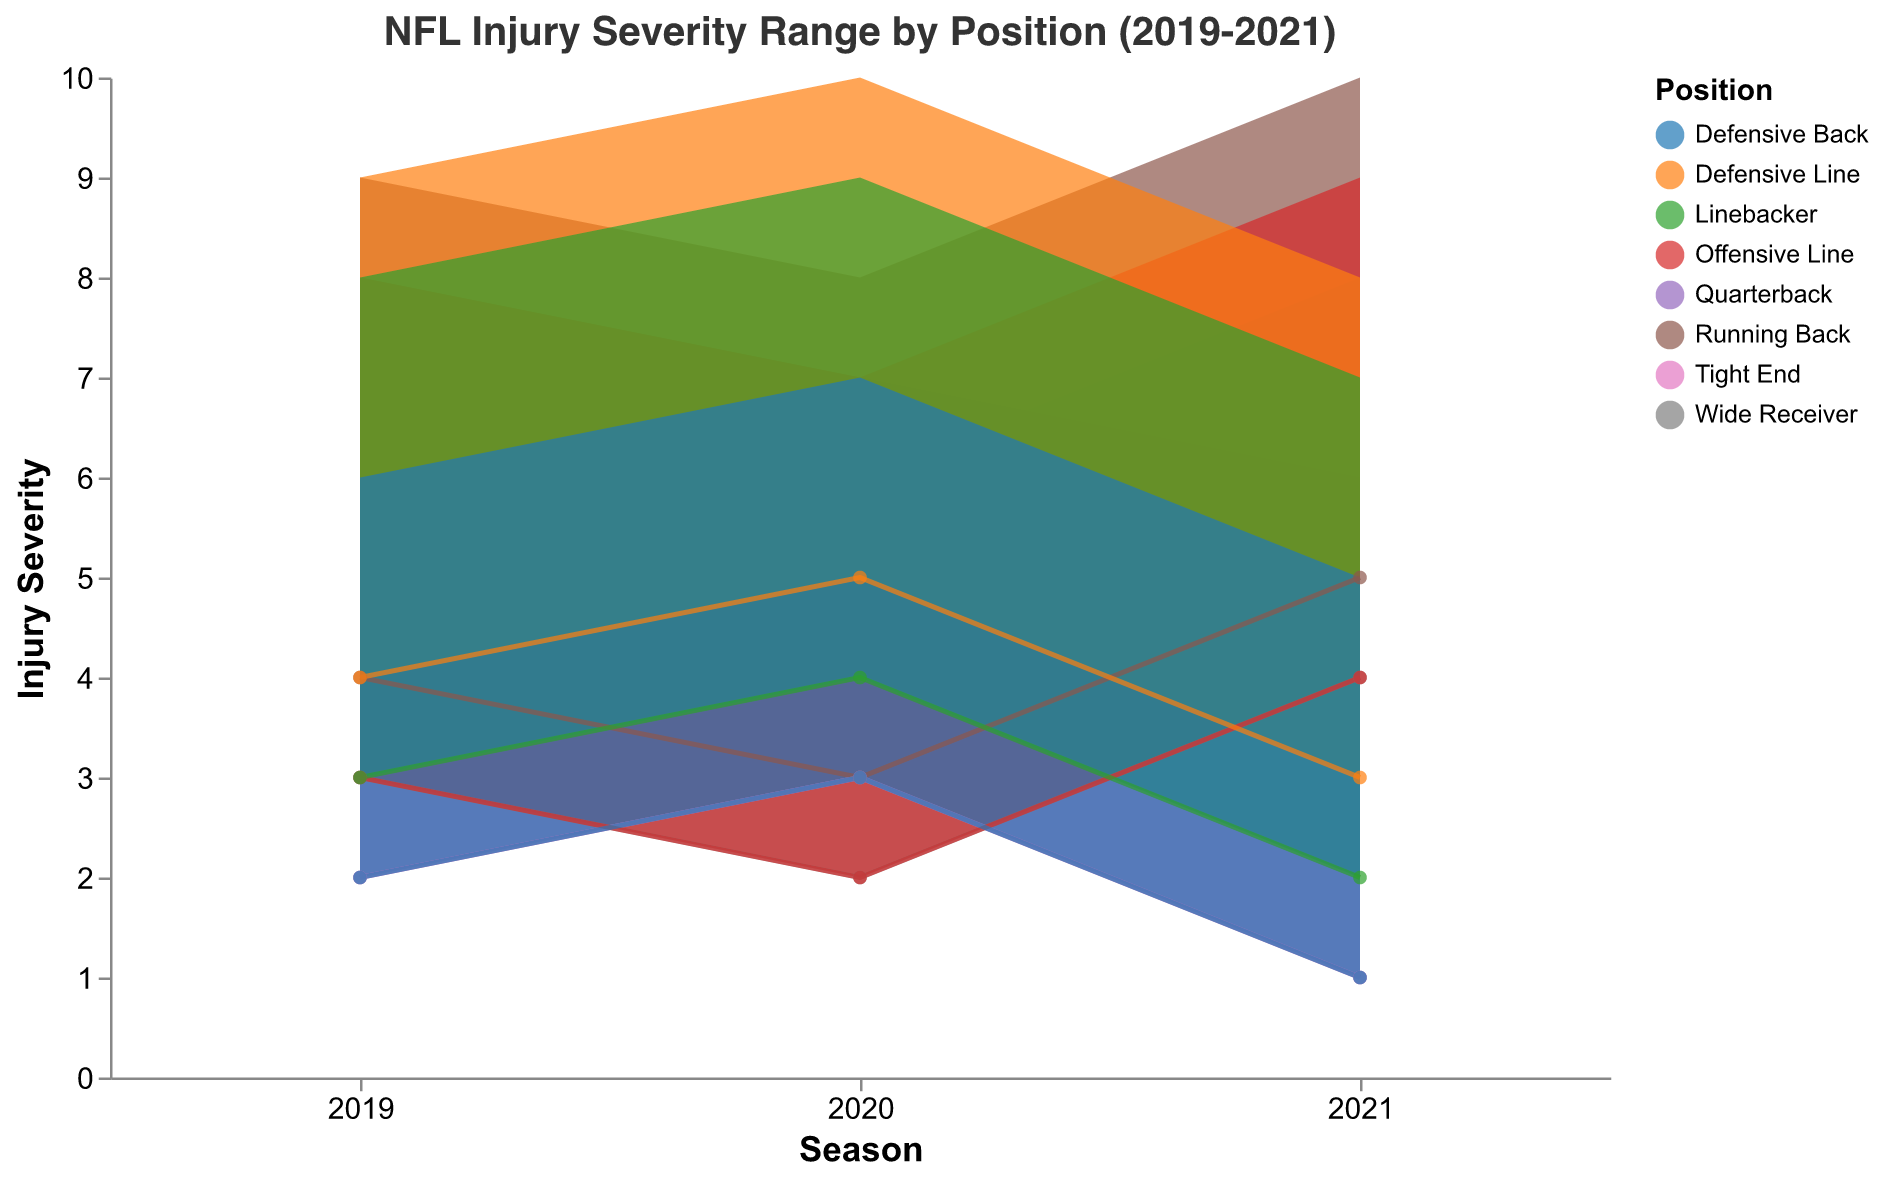What is the range of injury severity for Quarterbacks in the 2021 season? The minimum severity is 1 and the maximum severity is 6, so the range is 6 - 1 = 5.
Answer: 5 Which position had the highest maximum injury severity in 2021? By looking at the figure, the Running Back position had the highest maximum injury severity of 10 in 2021.
Answer: Running Back Compare the injury severity range of Linebackers between 2019 and 2021. Which season had a lower minimum severity? In 2019, the minimum severity for Linebackers was 3, and in 2021, it was 2. Therefore, 2021 had a lower minimum severity.
Answer: 2021 Which position had the least variability in injury severity in 2020? Variability in injury severity can be seen from the difference between max and min severity. By comparing, the Wide Receiver position had a min of 2 and max of 6, with a difference of 4, which is the smallest range among all positions in 2020.
Answer: Wide Receiver What is the median maximum injury severity for all positions in 2020? The maximum severities for each position in 2020 are 7 (Quarterback), 8 (Running Back), 6 (Wide Receiver), 7 (Tight End), 7 (Offensive Line), 10 (Defensive Line), 9 (Linebacker), 7 (Defensive Back). Sorting these, we get 6, 7, 7, 7, 7, 8, 9, 10. The median is the average of the 4th and 5th values (7 and 7), which is 7.
Answer: 7 Between Offensive Line and Defensive Line, which position showed an increase in injury severity range from 2019 to 2020? For Offensive Line, the range decreased from 8 - 3 = 5 in 2019 to 7 - 2 = 5 in 2020, so it did not change. For Defensive Line, the range increased from 9 - 4 = 5 in 2019 to 10 - 5 = 5 in 2020, so it also did not change.
Answer: Neither What can be inferred about the consistency of injury severity for the position of Tight End across the seasons? The Tight End position shows a decreasing trend in both minimum and maximum severity from 2020 to 2021, indicating a potential improvement in managing or preventing injuries.
Answer: Improved consistency Which position experienced the largest increase in minimum severity from 2020 to 2021? Compare the difference in minimum severity for each position: Quarterback (3 to 1), Running Back (3 to 5), Wide Receiver (2 to 4), Tight End (3 to 1), Offensive Line (2 to 4), Defensive Line (5 to 3), Linebacker (4 to 2), Defensive Back (3 to 1). The Running Back position has the largest increase from 3 to 5, an increase of 2.
Answer: Running Back How did the injury severity range for Defensive Backs change from 2019 to 2021? In 2019, the range was 6 - 2 = 4, and in 2021, it was 5 - 1 = 4. Therefore, the range remained the same.
Answer: Same 